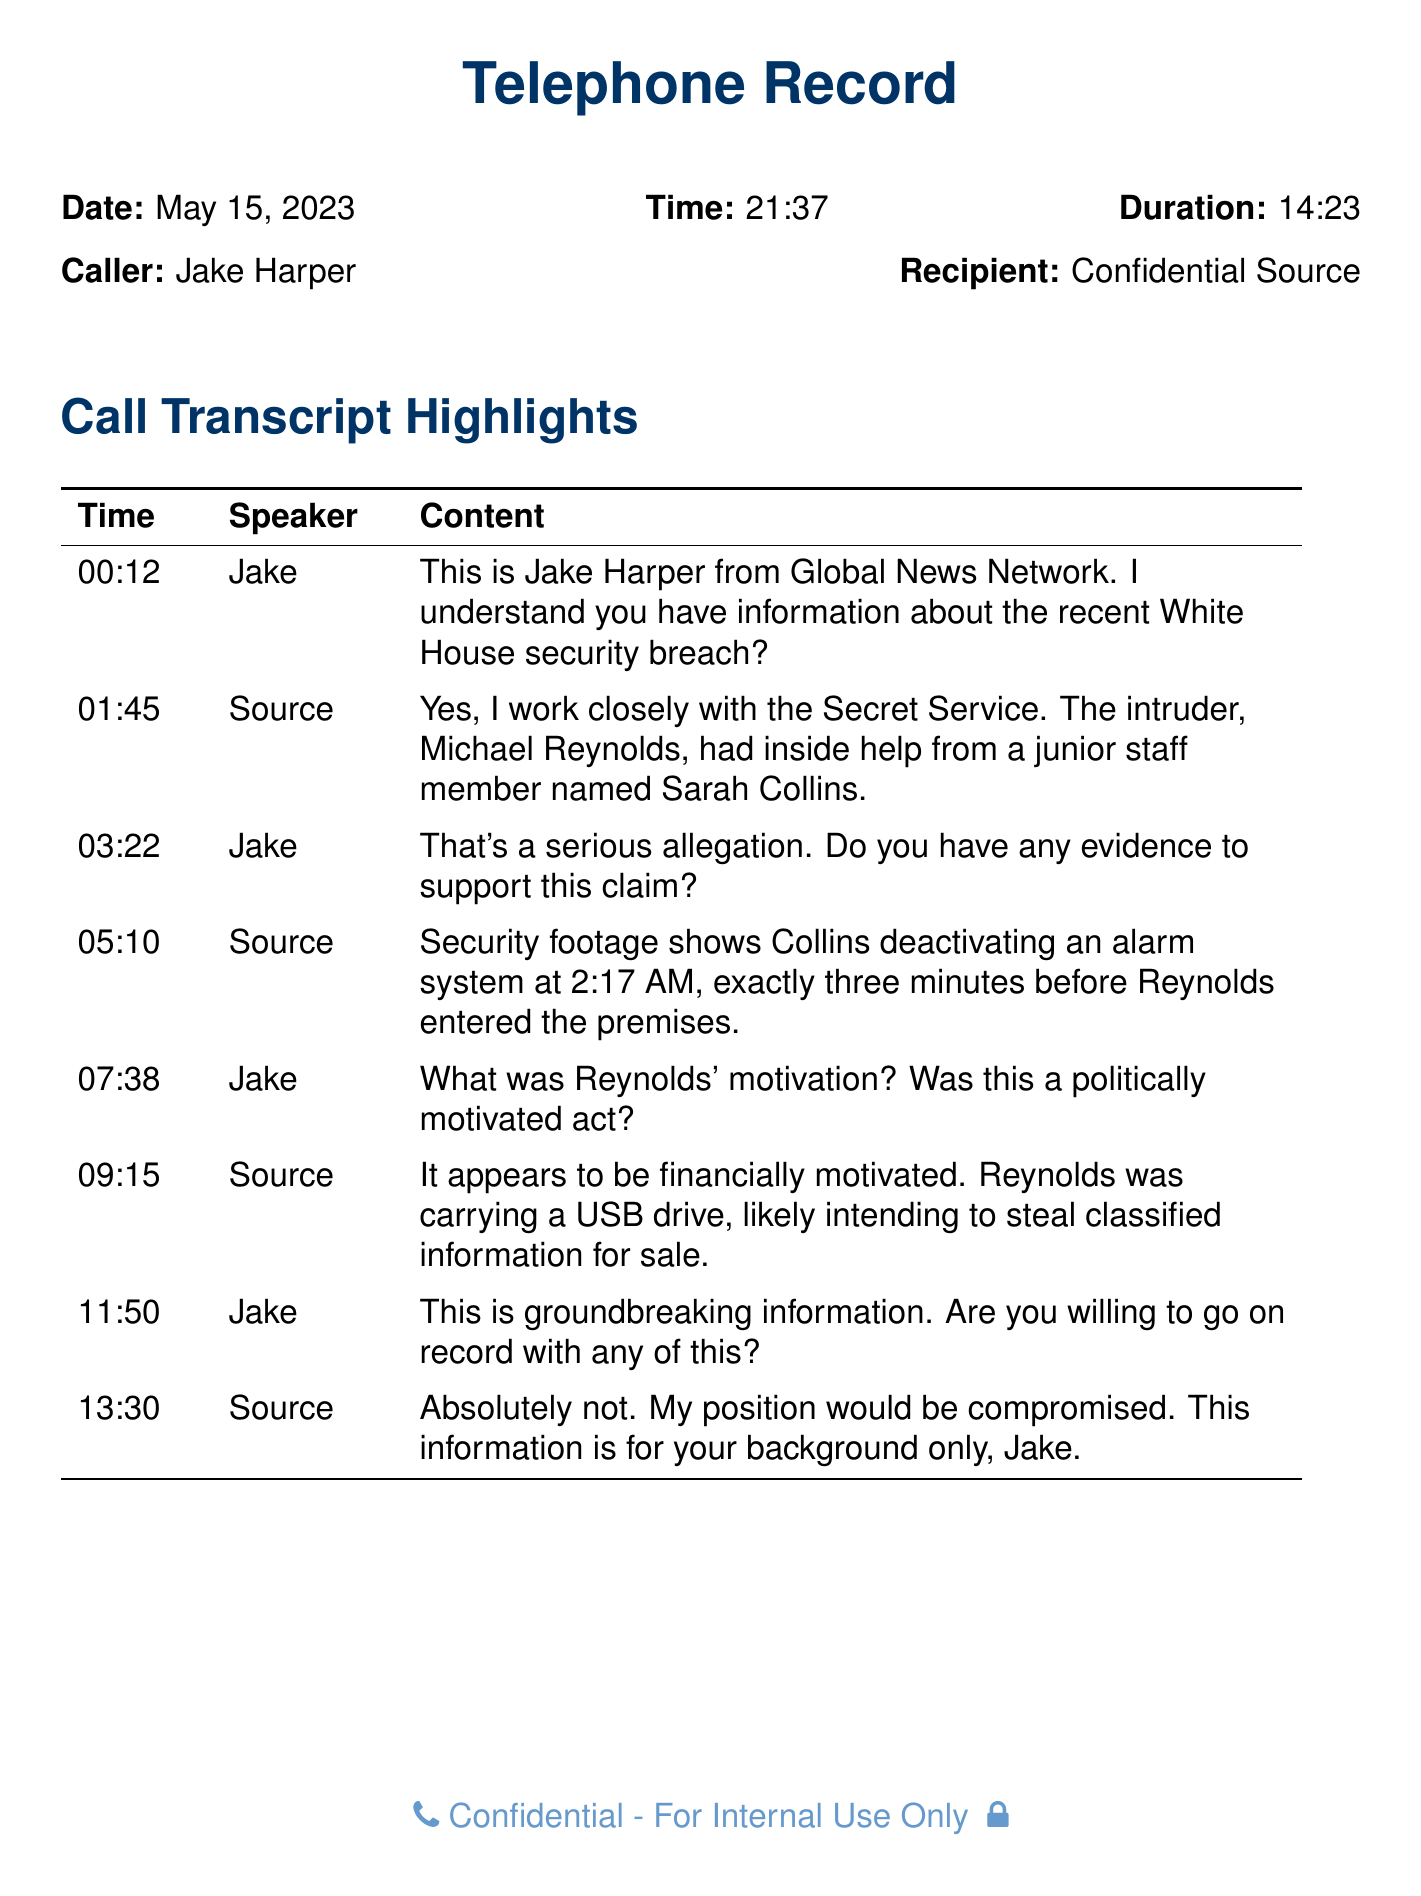What is the date of the call? The date of the call is explicitly mentioned at the top of the transcript.
Answer: May 15, 2023 Who is the caller in the conversation? The caller is identified at the beginning of the transcript.
Answer: Jake Harper What time does the call start? The start time of the call is noted right below the date in the transcript.
Answer: 21:37 How long did the conversation last? The duration of the call is specified alongside the date and time.
Answer: 14:23 What is the name of the intruder mentioned? The name of the intruder is provided in the exchange during the call.
Answer: Michael Reynolds What was the motivation behind the intrusion? The motivation is described in a response from the source during the conversation.
Answer: Financially motivated What security measure was deactivated before the intrusion? The specific security measure mentioned during the conversation is detailed in the source's statement.
Answer: Alarm system Is the source willing to go on record? The willingness of the source to share information on the record is clearly stated in the conversation.
Answer: Absolutely not What type of document is this? This document is characterized by its structure and content, which organizes a phone call exchange.
Answer: Telephone Record 